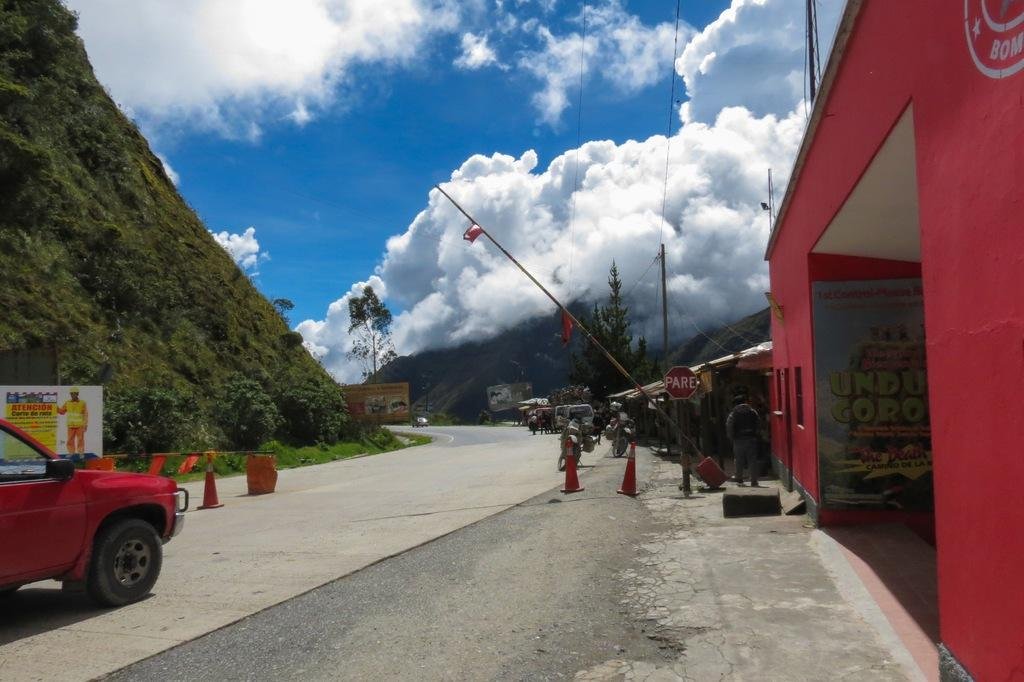What can be seen on the road in the image? There are vehicles on the road in the image. What is located on the right side of the image? There are buildings, trees, and poles on the right side of the image. What is present on the left side of the image? There are traffic cones and a hill on the left side of the image. What part of the natural environment is visible in the image? The sky is visible in the image. Where is the cap located in the image? There is no cap present in the image. What type of church can be seen in the image? There is no church present in the image. 